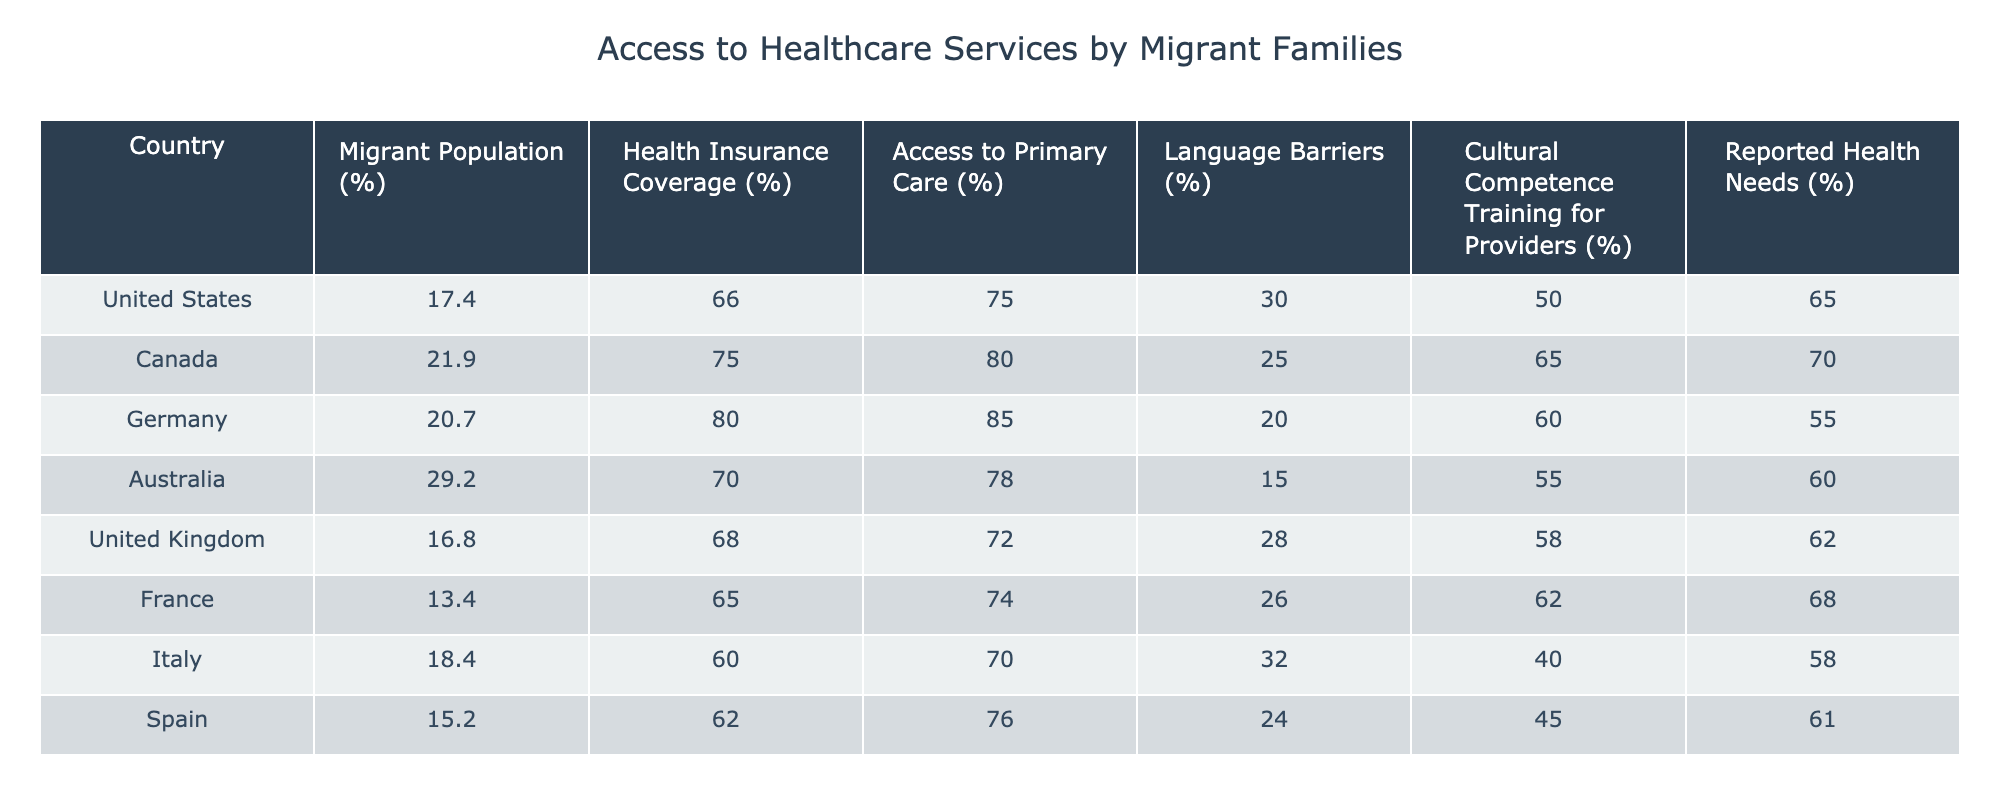What is the health insurance coverage percentage for Germany? The table shows the "Health Insurance Coverage (%)" column, where Germany's value is listed as 80.0%.
Answer: 80.0% Which country has the highest access to primary care? By reviewing the "Access to Primary Care (%)" column, Australia has the highest value of 78.0%.
Answer: Australia What is the difference in language barriers percentage between Canada and the United Kingdom? Looking at the "Language Barriers (%)" column, Canada has 25.0% and the United Kingdom has 28.0%. The difference is 28.0% - 25.0% = 3.0%.
Answer: 3.0% Do more than 60% of migrant families report health needs in the United States? In the "Reported Health Needs (%)" column, the value for the United States is 65.0%, which is greater than 60%. Therefore, the answer is yes.
Answer: Yes What is the average health insurance coverage percentage among the listed countries? To find the average, we sum the health insurance coverage percentages: (66.0 + 75.0 + 80.0 + 70.0 + 68.0 + 65.0 + 60.0 + 62.0) = 586.0 and divide by 8, leading to an average of 586.0 / 8 = 73.25%.
Answer: 73.25% Which country has the lowest cultural competence training for healthcare providers? In the "Cultural Competence Training for Providers (%)" column, Italy has the lowest value at 40.0%.
Answer: Italy Are language barriers highest in France compared to the other countries listed? The table indicates that France has 26.0% in the "Language Barriers (%)" column, which is lower than other countries like Italy at 32.0%, so the answer is no.
Answer: No What is the total percentage of migrant families with access to healthcare services in Canada and Germany? The "Access to Primary Care (%)" for Canada is 80.0% and for Germany is 85.0%. Summing these values gives 80.0% + 85.0% = 165.0%.
Answer: 165.0% Which country has a higher percentage of health insurance coverage: Italy or Spain? In the "Health Insurance Coverage (%)" column, Italy is at 60.0% and Spain is at 62.0%. Since 62.0% is greater, Spain has the higher percentage.
Answer: Spain 